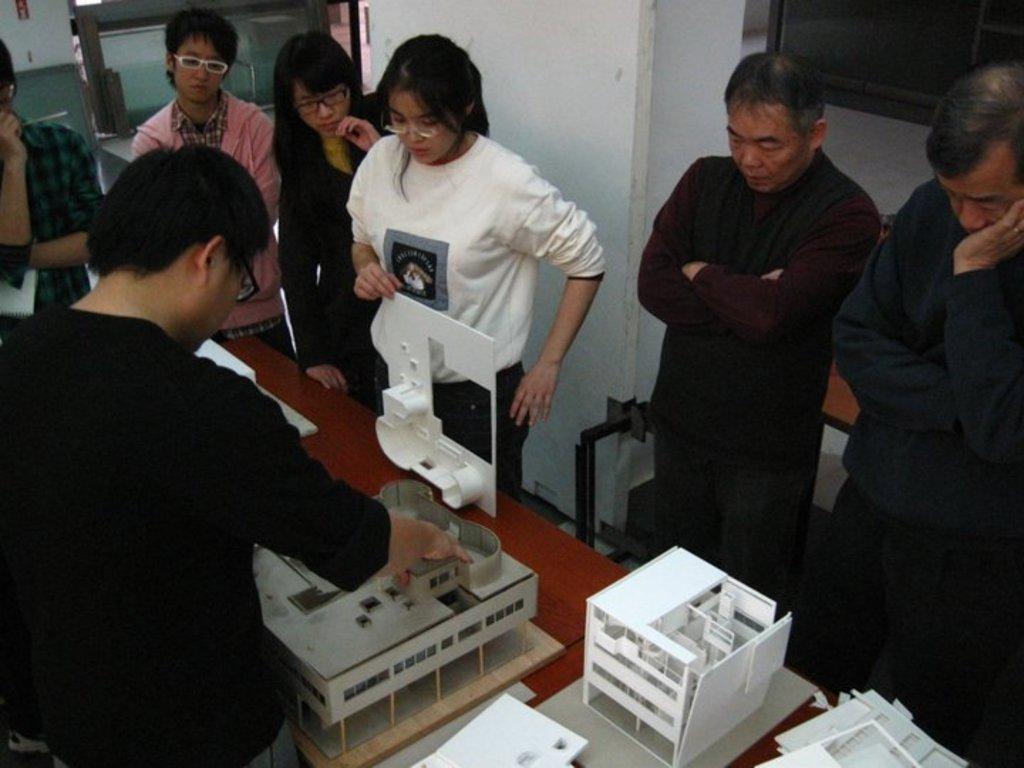Describe this image in one or two sentences. In the image there are few women and men standing on either side of table with a plan of a building on it, behind them there is a pillar. 